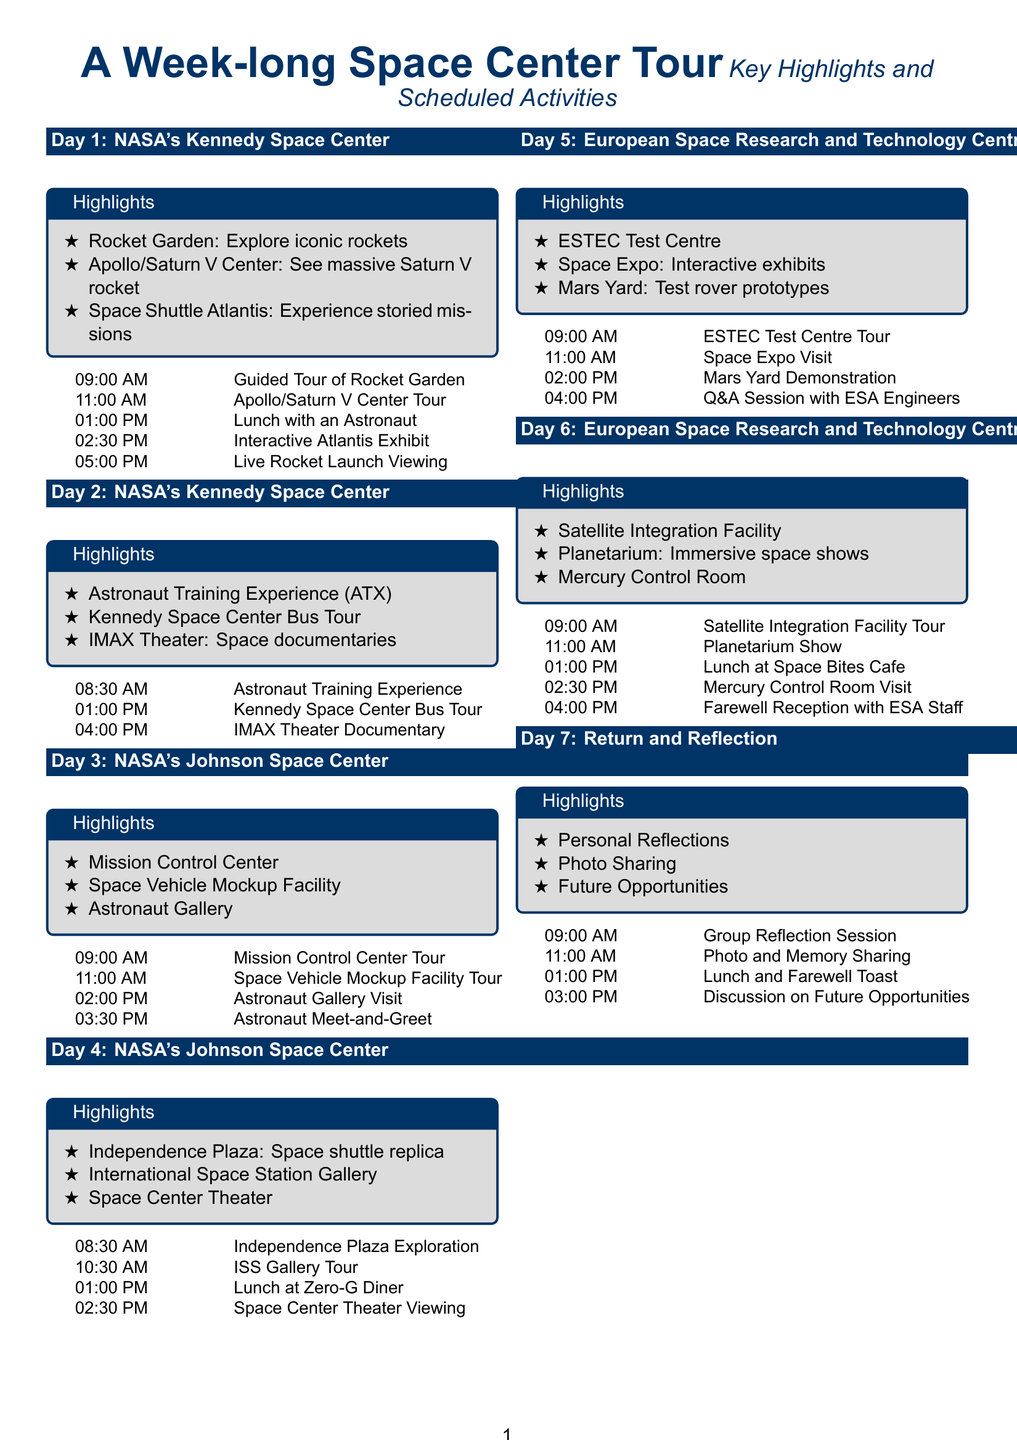What is the first location visited on Day 1? The first location visited on Day 1 is NASA's Kennedy Space Center.
Answer: NASA's Kennedy Space Center How many highlights are listed for Day 3? There are three highlights listed for Day 3.
Answer: 3 What time does the guided tour of the Rocket Garden start? The guided tour of the Rocket Garden starts at 09:00 AM.
Answer: 09:00 AM What type of show is featured on Day 6 at the Planetarium? The show featured on Day 6 at the Planetarium is immersive space shows.
Answer: Immersive space shows What activity occurs at 11:00 AM on Day 5? At 11:00 AM on Day 5, there's a visit to the Space Expo.
Answer: Space Expo Visit What is the main focus of the farewell reception on Day 6? The main focus of the farewell reception on Day 6 is with ESA Staff.
Answer: ESA Staff How many total days does the itinerary cover? The itinerary covers a total of seven days.
Answer: 7 What is the last scheduled activity before the reflection session? The last scheduled activity before the reflection session is photo and memory sharing.
Answer: Photo and Memory Sharing 